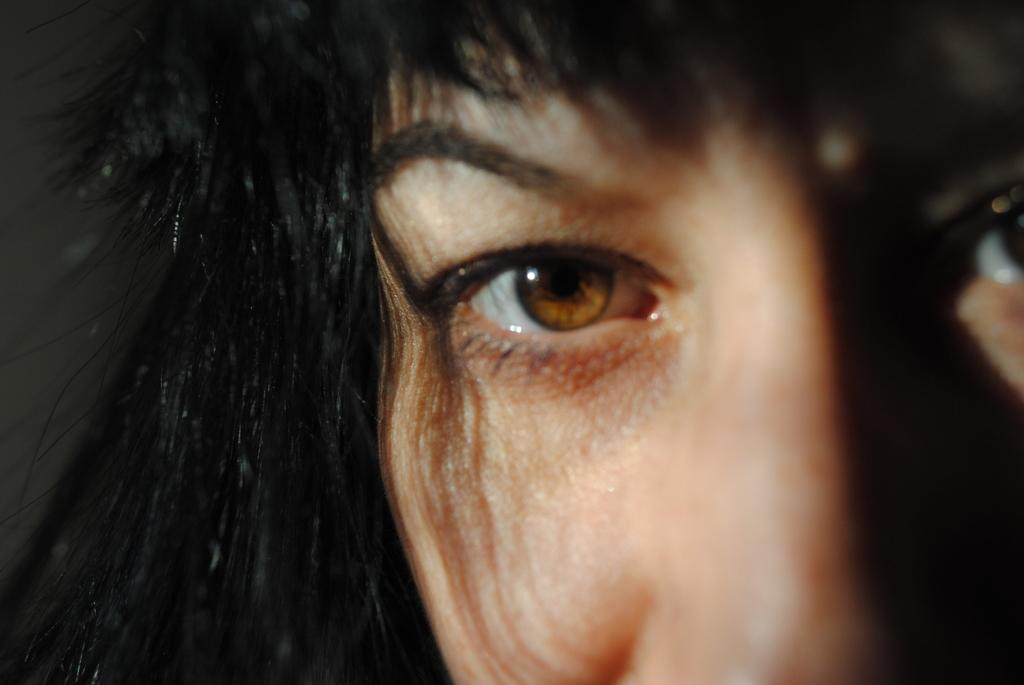What is present in the image? There is a person in the image. What facial features of the person can be seen? The person's eyes and nose are visible in the image. What else about the person can be observed? The person's hair is visible in the image. What is the person's interest in the town? There is no information about the person's interest in the town, as the image only shows the person's facial features. 